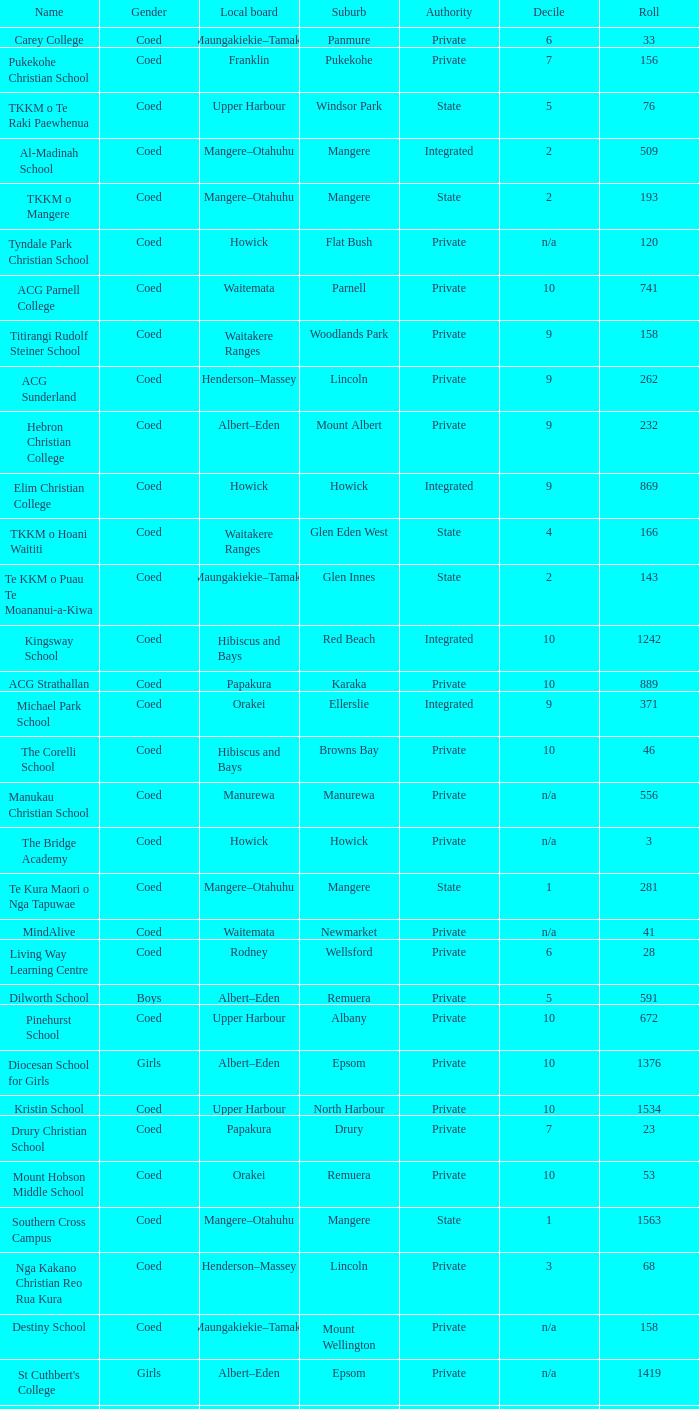What is the name of the suburb with a roll of 741? Parnell. 